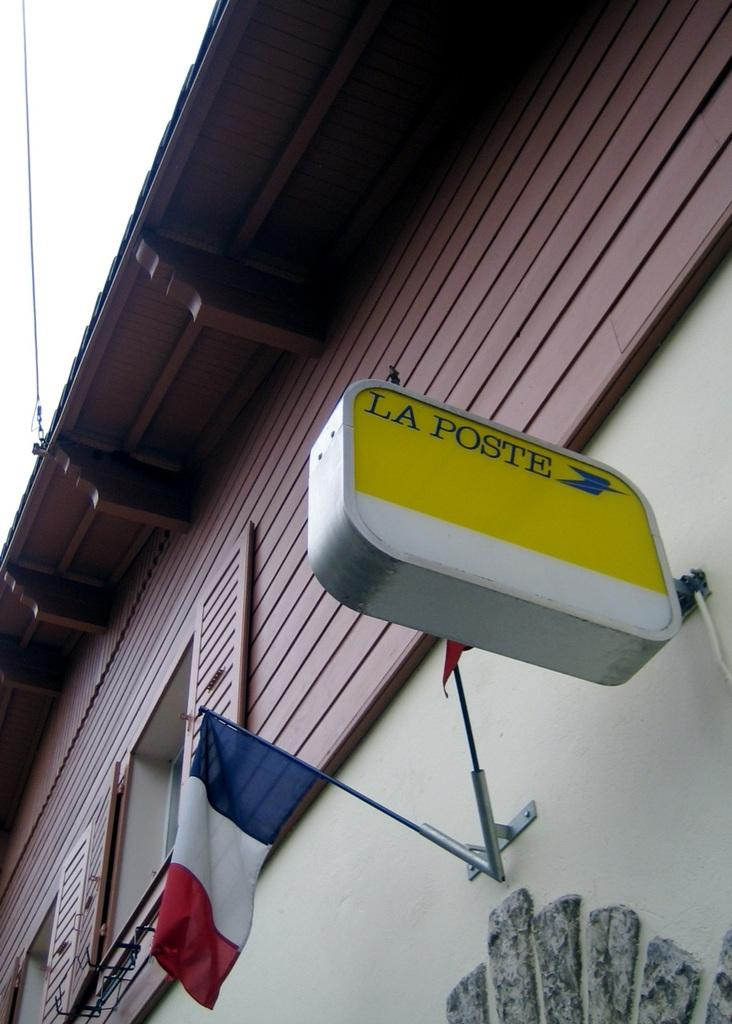What is located in the foreground of the image? There is a board in the foreground of the image. What can be seen on the wall in the image? There is a flag on the wall in the image. Is there any opening to the outside visible in the image? Yes, there is a window visible in the image. What is visible on the right side of the image? The sky is visible on the right side of the image. What type of skirt is hanging on the wall next to the flag? There is no skirt present in the image. 